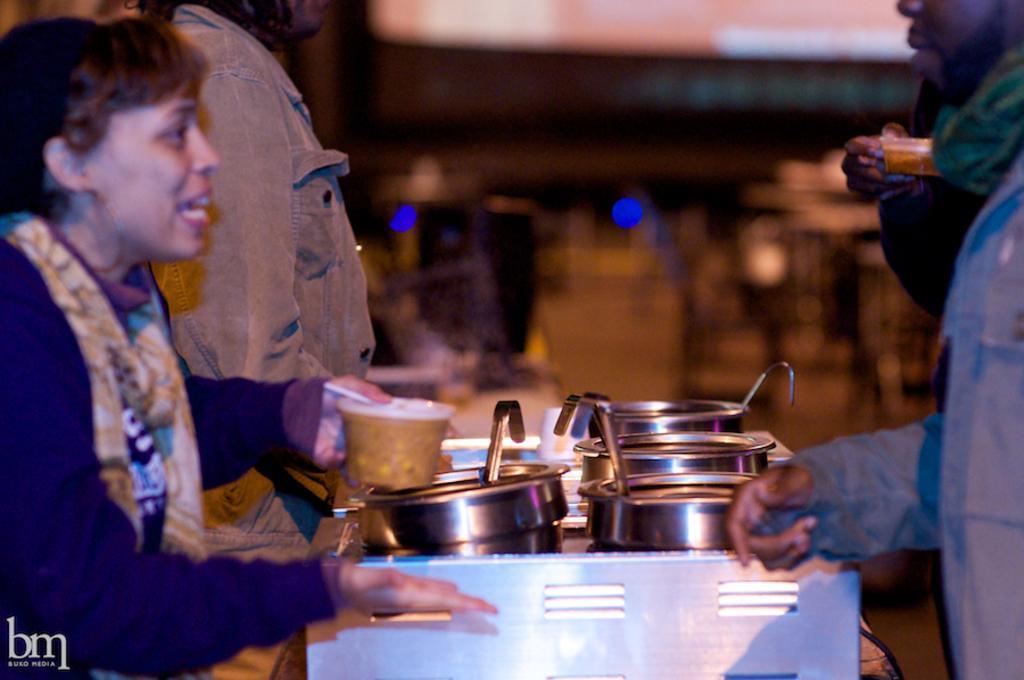Describe this image in one or two sentences. In this picture we can see a few vessels and spoons on an object. There is a woman holding a box in her hand. We can see a person on the left side. There is another person on the right side. Few lights are visible in the background. We can see a watermark on bottom left. 